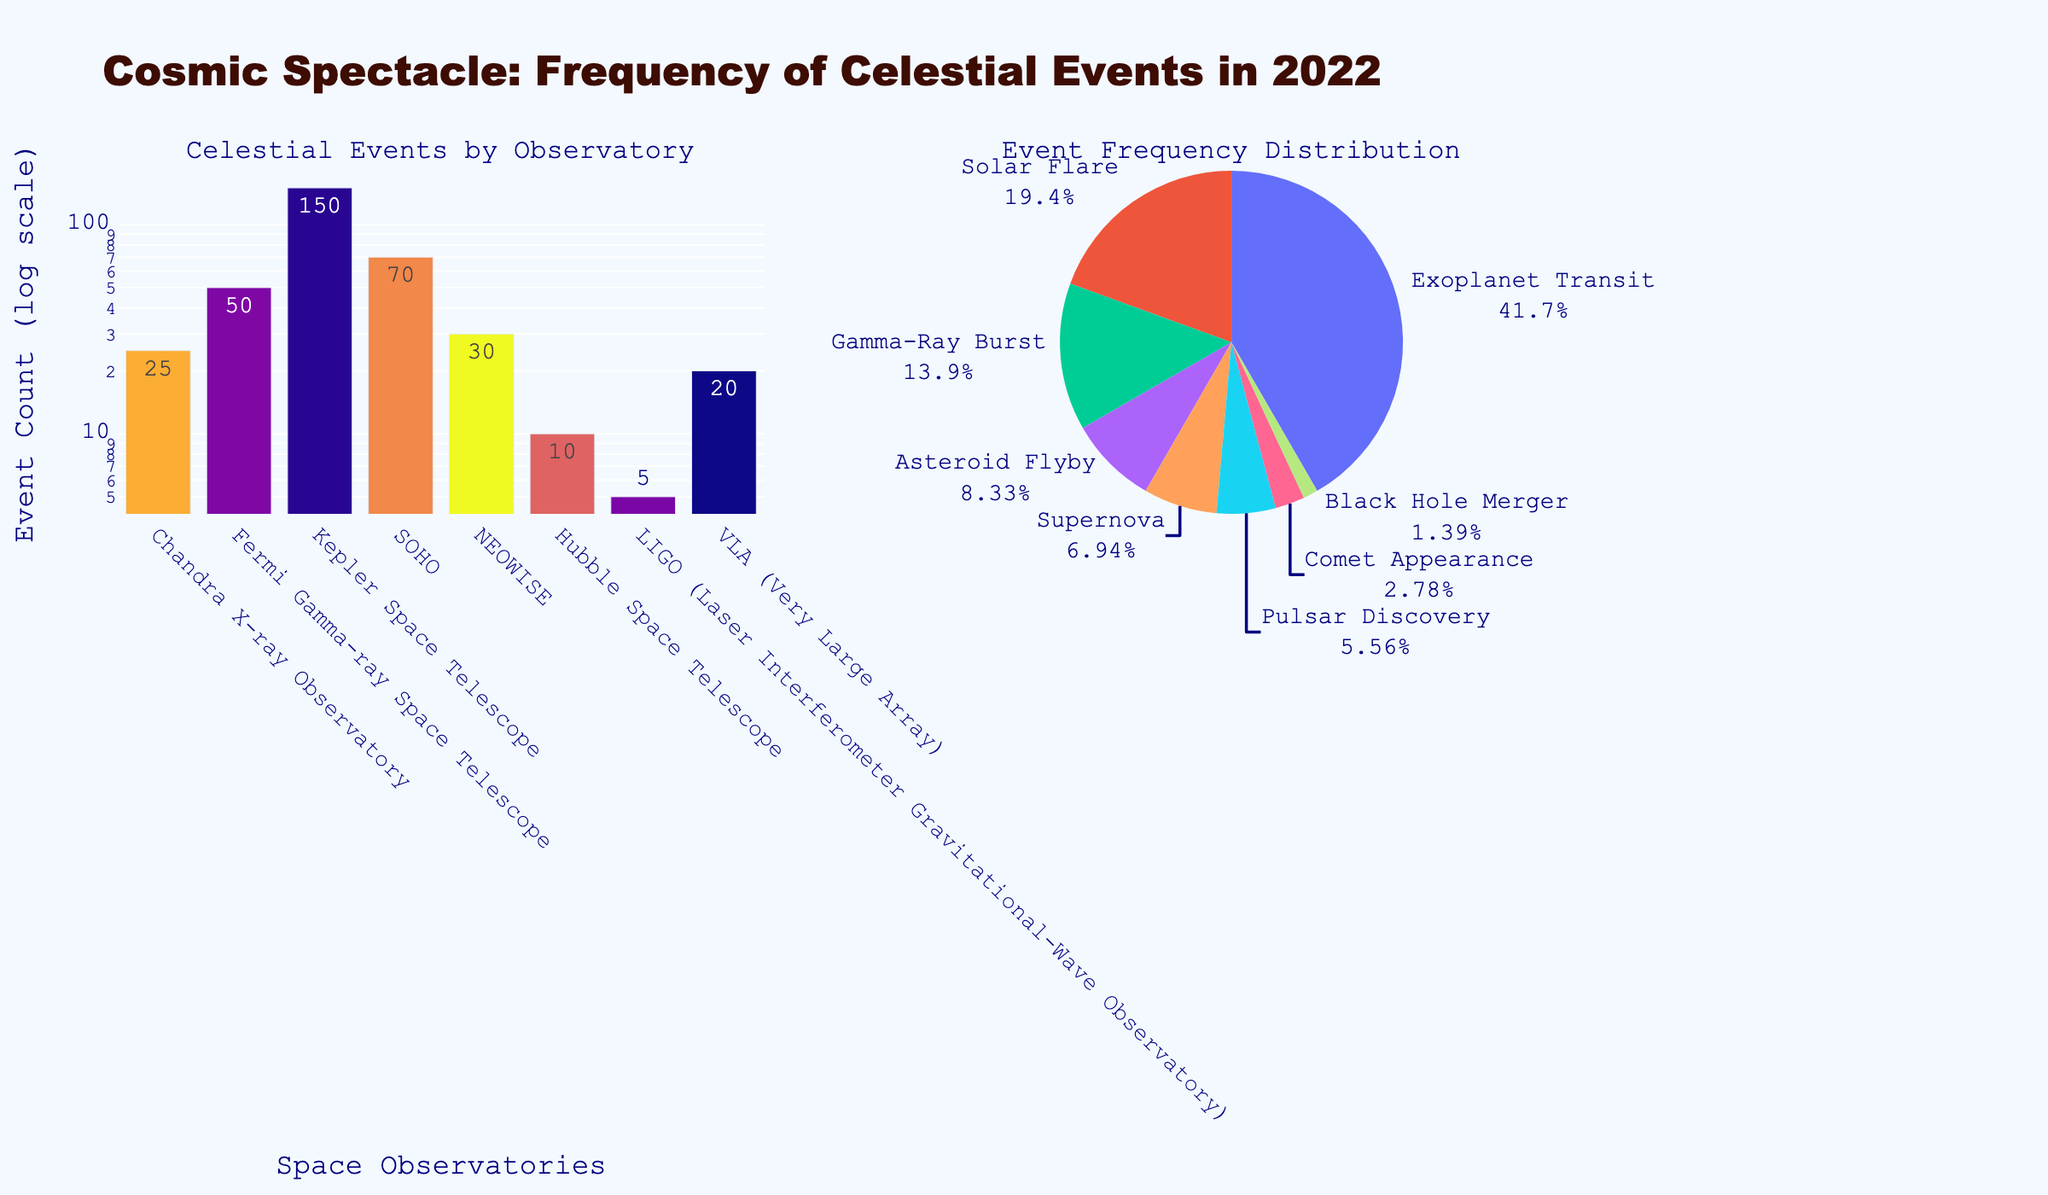Which celestial event had the highest count in 2022? By looking at the pie chart, we observe that "Exoplanet Transit" has the largest section, which indicates the highest count. Also, the bar chart shows that "Kepler Space Telescope" has 150 events recorded, showing the highest bar.
Answer: Exoplanet Transit What is the log-scaled frequency for Solar Flares recorded by SOHO in 2022? The bar chart uses a log scale for the y-axis, and the count for Solar Flares is 70. On a log scale, it is represented near 10^1.8 or between 10 and 100.
Answer: About 70 Which space observatory recorded the least number of celestial events in 2022? From the bar chart, we can see that the shortest bar belongs to "LIGO," and from the pie chart, "Black Hole Merger" has the smallest section.
Answer: LIGO How does the count of Asteroid Flybys compare with Pulsar Discoveries? Observing the bar chart, we see that "VLA" recorded 20 Pulsar Discoveries, whereas "NEOWISE" recorded 30 Asteroid Flybys. Therefore, there are more Asteroid Flybys than Pulsar Discoveries.
Answer: More Asteroid Flybys What is the sum of counts for celestial events recorded by Chandra X-ray Observatory and VLA? We refer to the bar chart and sum the counts for "Chandra X-ray Observatory" (25 Supernova events) and "VLA" (20 Pulsar Discoveries). 25 + 20 = 45
Answer: 45 Which event takes up about 8% of the frequency distribution? By analyzing the pie chart, we see that “Comet Appearance” holds a small section of about 8%, represented by "Hubble Space Telescope" with a count of 10.
Answer: Comet Appearance How many more Gamma-Ray Bursts were recorded than Supernovae? In the bar chart, "Fermi Gamma-ray Space Telescope" recorded 50 Gamma-Ray Bursts, while "Chandra X-ray Observatory" recorded 25 Supernovae. The difference is 50 - 25.
Answer: 25 more Which observatory recorded fewer than 10 celestial events in 2022? Observing the bar chart, we see that "LIGO" is the only observatory with a count of 5 for Black Hole Mergers, which is fewer than 10.
Answer: LIGO What event has about double the frequency of Asteroid Flybys? The bar chart shows "NEOWISE" has 30 counts for Asteroid Flybys. The event with about double this frequency is "SOHO" with 70 Solar Flares (close to 60).
Answer: Solar Flare What is the average count of celestial events recorded across all observatories? To find the average, sum the count values from the bar chart (25+50+150+70+30+10+5+20=360) and divide by the number of observatories (8): 360/8 = 45
Answer: 45 